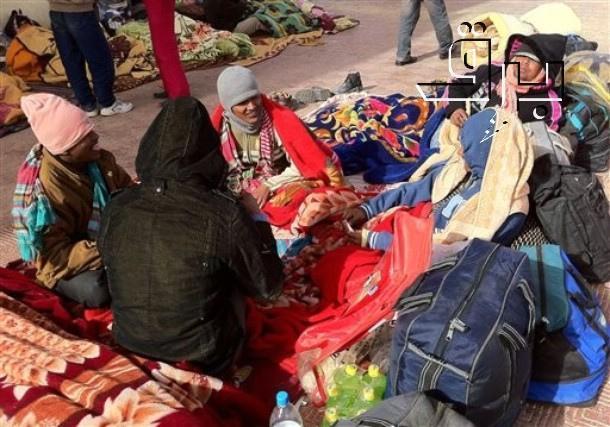How many people can we see standing?
Give a very brief answer. 3. How many people are there?
Give a very brief answer. 9. How many suitcases are there?
Give a very brief answer. 2. How many backpacks are visible?
Give a very brief answer. 4. 